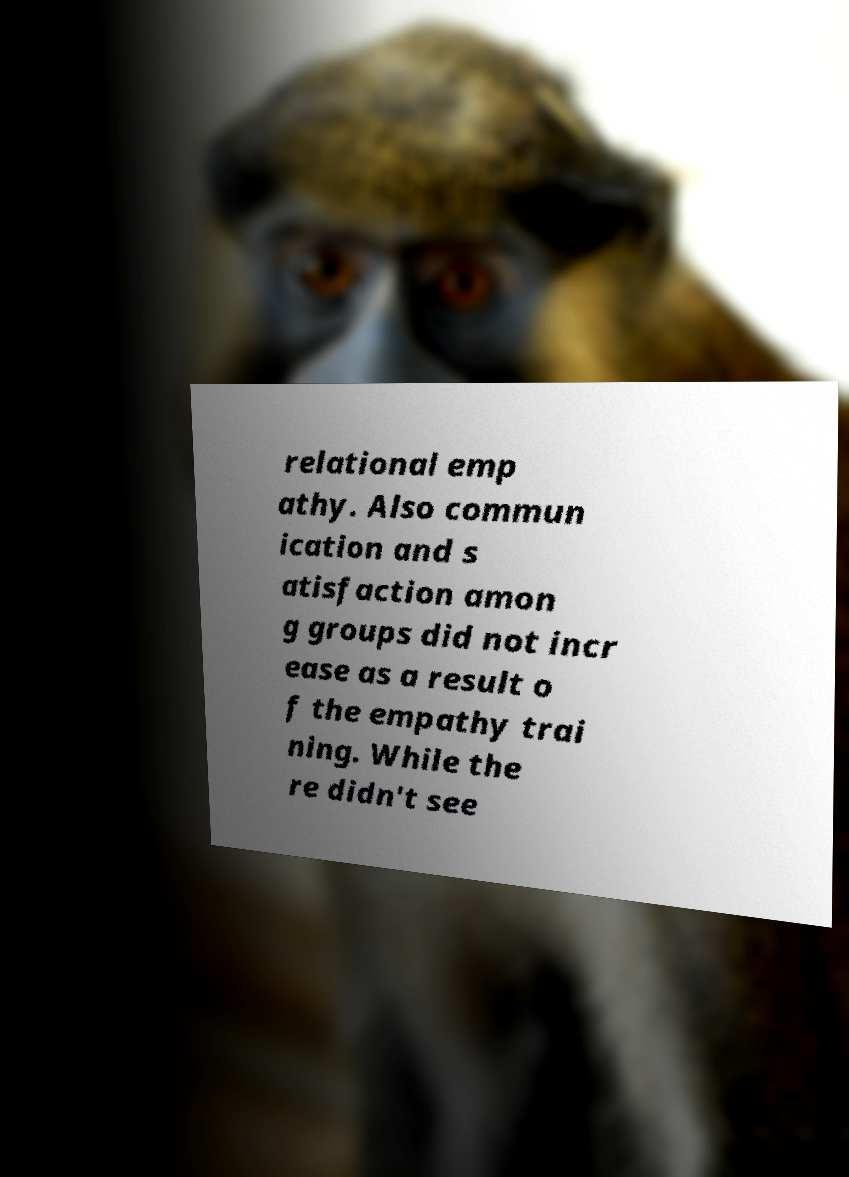Can you read and provide the text displayed in the image?This photo seems to have some interesting text. Can you extract and type it out for me? relational emp athy. Also commun ication and s atisfaction amon g groups did not incr ease as a result o f the empathy trai ning. While the re didn't see 